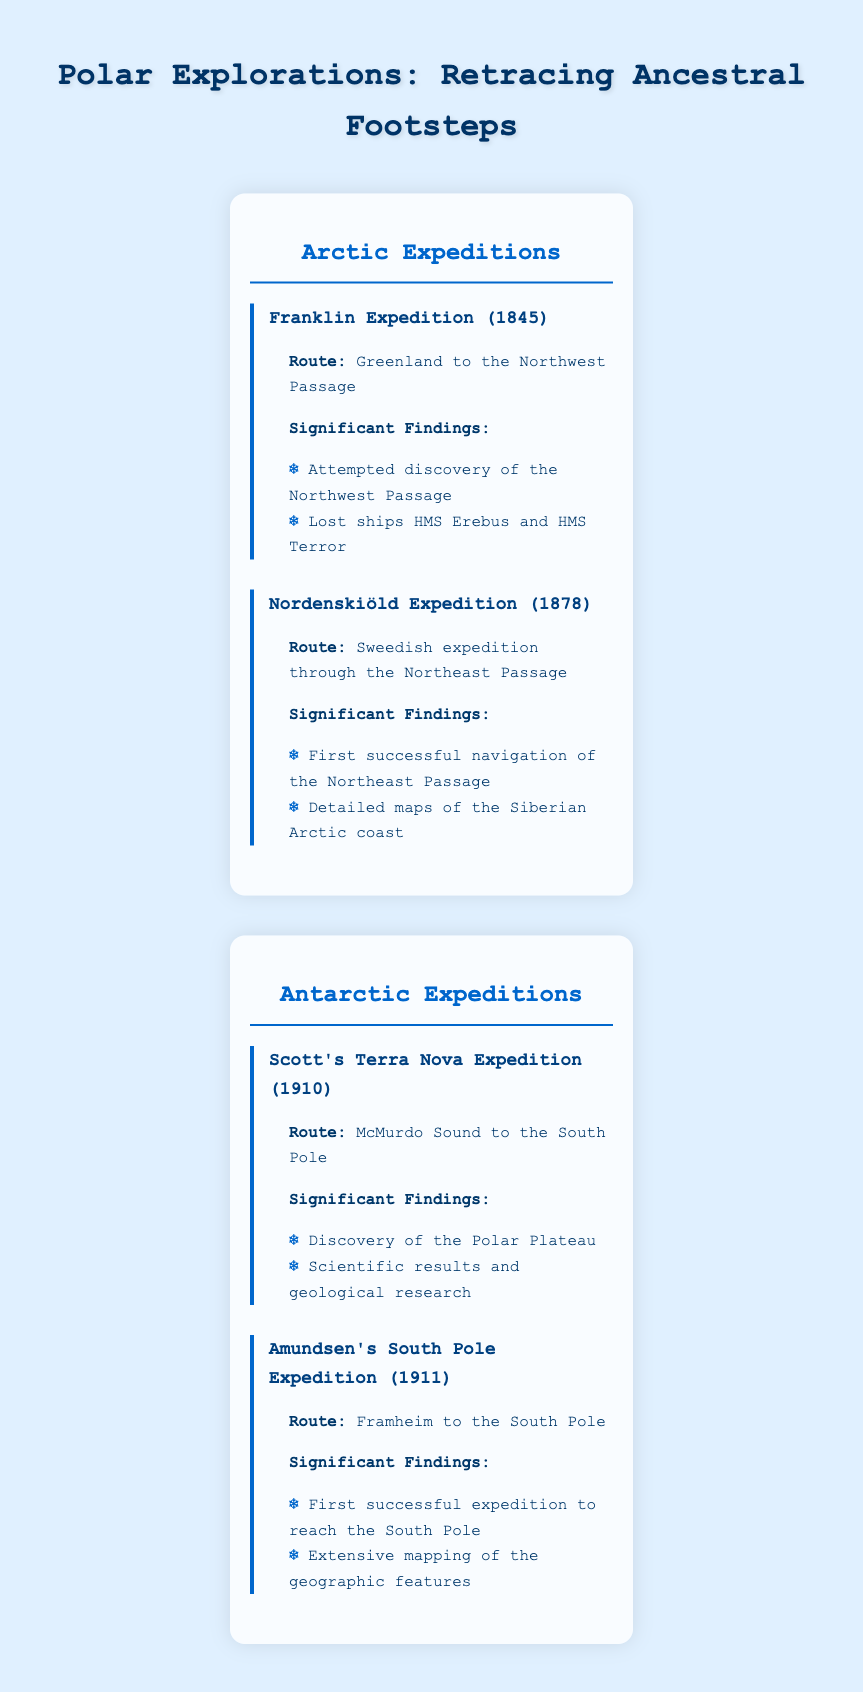What was the route of the Franklin Expedition? The table lists the route of the Franklin Expedition as "Greenland to the Northwest Passage." This can be found directly under the details for the Franklin Expedition entry.
Answer: Greenland to the Northwest Passage Which expedition attempted to discover the Northwest Passage? The table shows that the Franklin Expedition aimed at discovering the Northwest Passage. This is mentioned in the "Significant Findings" for that specific expedition.
Answer: Franklin Expedition How many expeditions are listed for the Antarctic region? The table shows two expeditions listed under the Antarctic region: Scott's Terra Nova Expedition and Amundsen's South Pole Expedition. Counting the entries gives a total of two expeditions.
Answer: 2 Did the Nordenskiöld Expedition result in mapping the Siberian Arctic coast? According to the table, the Nordenskiöld Expedition is noted for "detailed maps of the Siberian Arctic coast," which confirms that the expedition did indeed result in such findings.
Answer: Yes Which expedition was the first to reach the South Pole? The table specifies that Amundsen's South Pole Expedition was the first successful expedition to reach the South Pole. This is explicitly indicated in the "Significant Findings."
Answer: Amundsen's South Pole Expedition What was the year of Scott's Terra Nova Expedition and did it result in mapping? Scott's Terra Nova Expedition occurred in 1910, and according to the table, it resulted in significant geological research, but it does not specifically mention mapping. Thus, the answer includes both the year and finding context.
Answer: 1910, No Which expedition had significant findings about the Polar Plateau? The table indicates that Scott's Terra Nova Expedition had findings related to the discovery of the Polar Plateau. This is stated under the "Significant Findings" section of that expedition's details.
Answer: Scott's Terra Nova Expedition What is the difference in years between the Franklin Expedition and Amundsen's South Pole Expedition? The Franklin Expedition took place in 1845, and Amundsen's South Pole Expedition occurred in 1911. Subtracting these years gives 1911 - 1845 = 66 years.
Answer: 66 years List the significant findings of the Nordenskiöld Expedition. The table outlines two significant findings for the Nordenskiöld Expedition: "First successful navigation of the Northeast Passage" and "Detailed maps of the Siberian Arctic coast." These can be derived by directly referencing the Nordenskiöld Expedition details.
Answer: First successful navigation of the Northeast Passage; Detailed maps of the Siberian Arctic coast 